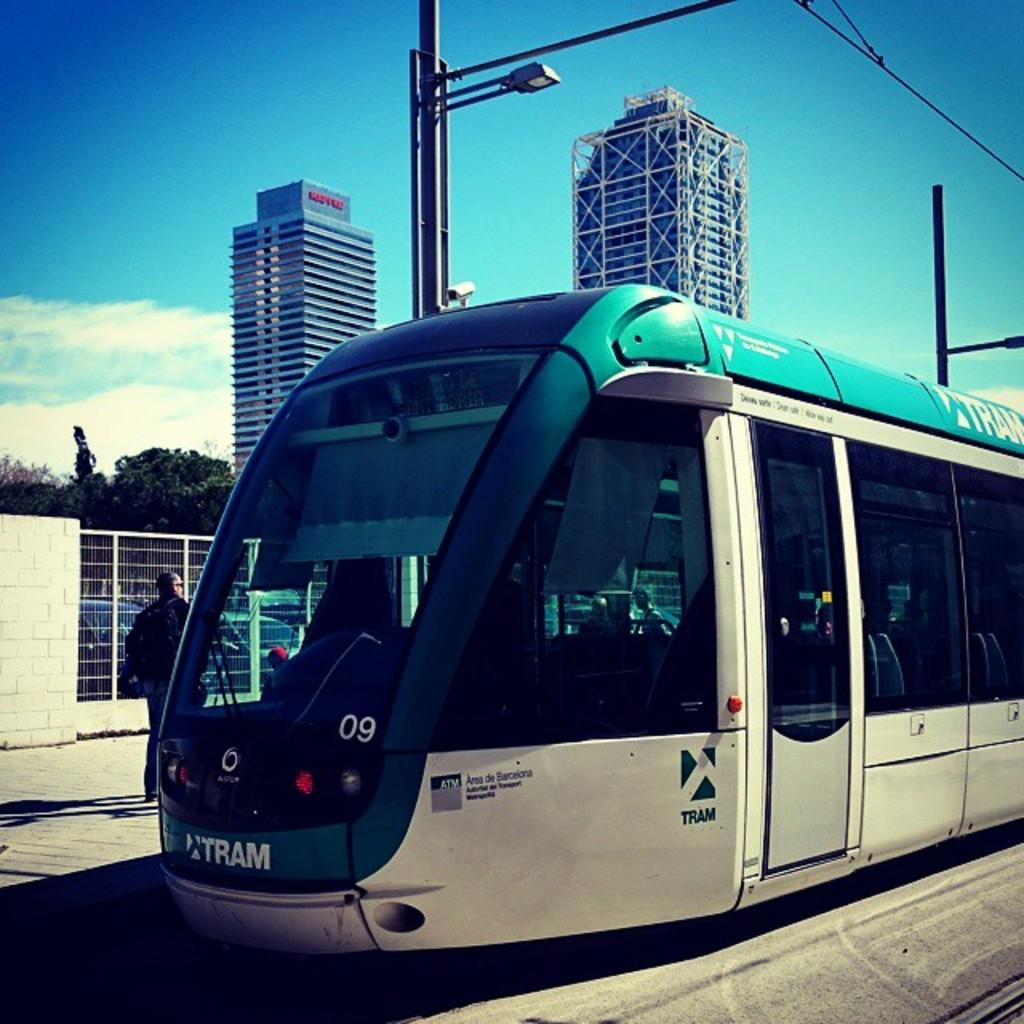What is the main subject of the image? The main subject of the image is a train. Can you describe any other objects or features in the image? Yes, there is a light, a CCTV camera, poles, wires, people, trees, buildings, and the sky visible in the image. How many oranges are being sold by the beast in the image? There is no beast or oranges present in the image. What type of business is being conducted by the people in the image? The image does not provide information about any business being conducted by the people. 